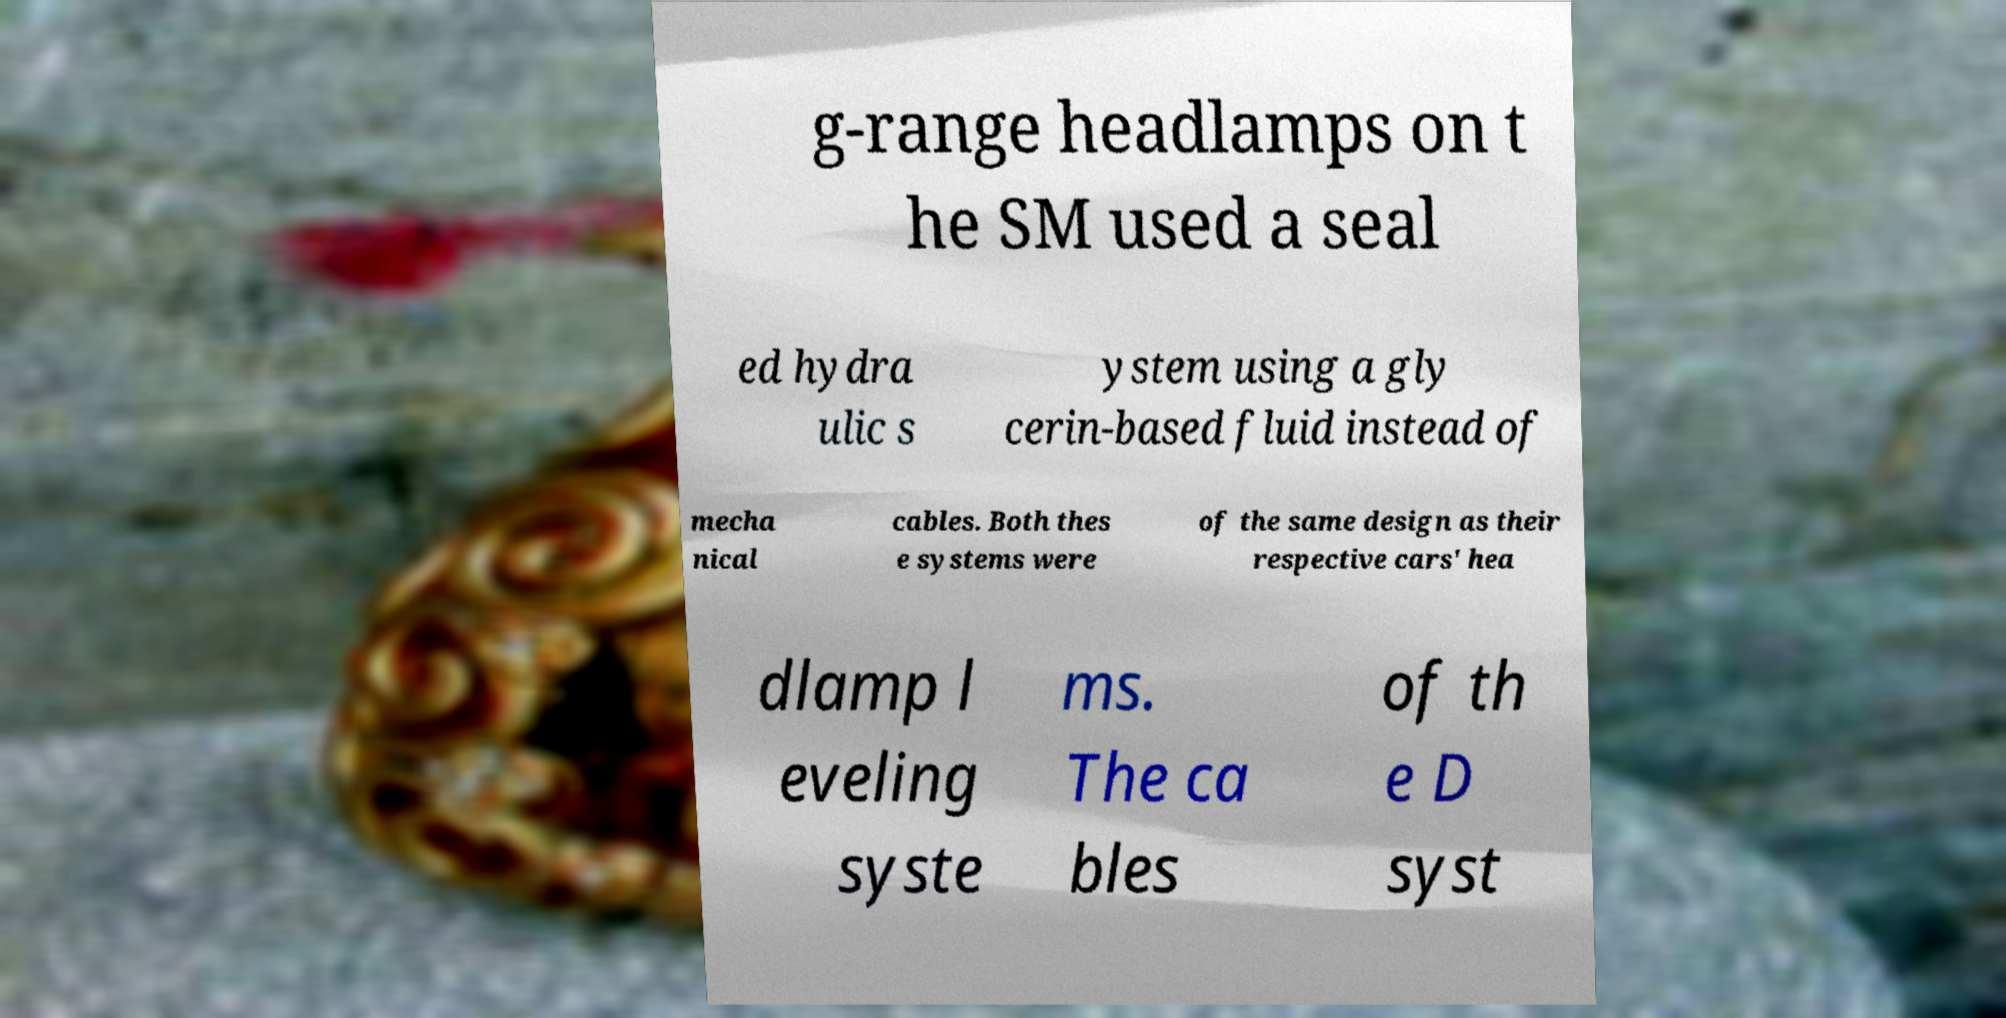There's text embedded in this image that I need extracted. Can you transcribe it verbatim? g-range headlamps on t he SM used a seal ed hydra ulic s ystem using a gly cerin-based fluid instead of mecha nical cables. Both thes e systems were of the same design as their respective cars' hea dlamp l eveling syste ms. The ca bles of th e D syst 